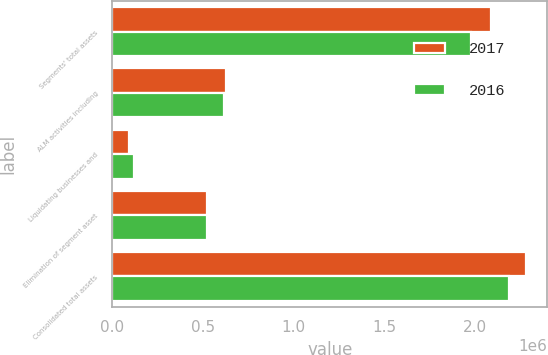Convert chart. <chart><loc_0><loc_0><loc_500><loc_500><stacked_bar_chart><ecel><fcel>Segments' total assets<fcel>ALM activities including<fcel>Liquidating businesses and<fcel>Elimination of segment asset<fcel>Consolidated total assets<nl><fcel>2017<fcel>2.08719e+06<fcel>625488<fcel>89008<fcel>520448<fcel>2.28123e+06<nl><fcel>2016<fcel>1.97565e+06<fcel>612996<fcel>118073<fcel>518656<fcel>2.18807e+06<nl></chart> 